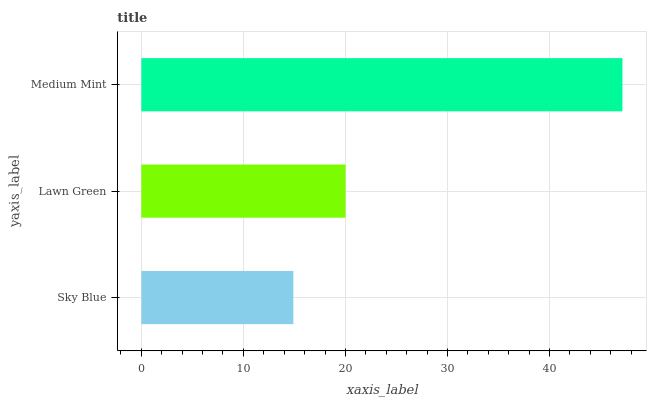Is Sky Blue the minimum?
Answer yes or no. Yes. Is Medium Mint the maximum?
Answer yes or no. Yes. Is Lawn Green the minimum?
Answer yes or no. No. Is Lawn Green the maximum?
Answer yes or no. No. Is Lawn Green greater than Sky Blue?
Answer yes or no. Yes. Is Sky Blue less than Lawn Green?
Answer yes or no. Yes. Is Sky Blue greater than Lawn Green?
Answer yes or no. No. Is Lawn Green less than Sky Blue?
Answer yes or no. No. Is Lawn Green the high median?
Answer yes or no. Yes. Is Lawn Green the low median?
Answer yes or no. Yes. Is Medium Mint the high median?
Answer yes or no. No. Is Medium Mint the low median?
Answer yes or no. No. 